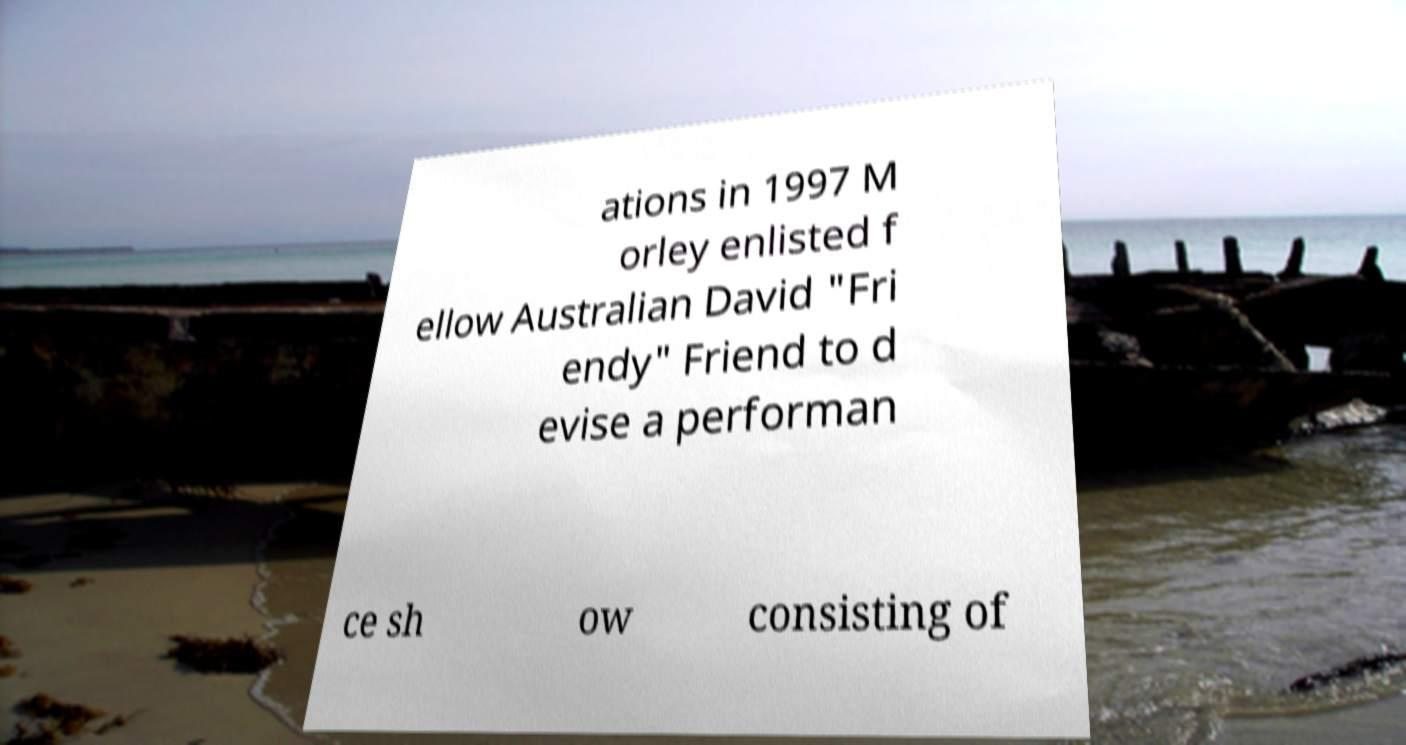Please identify and transcribe the text found in this image. ations in 1997 M orley enlisted f ellow Australian David "Fri endy" Friend to d evise a performan ce sh ow consisting of 